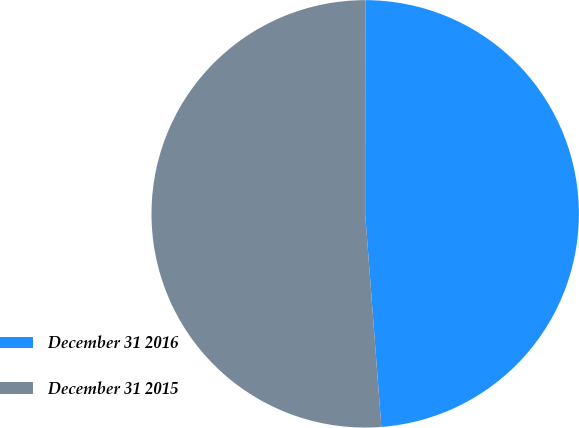Convert chart to OTSL. <chart><loc_0><loc_0><loc_500><loc_500><pie_chart><fcel>December 31 2016<fcel>December 31 2015<nl><fcel>48.78%<fcel>51.22%<nl></chart> 